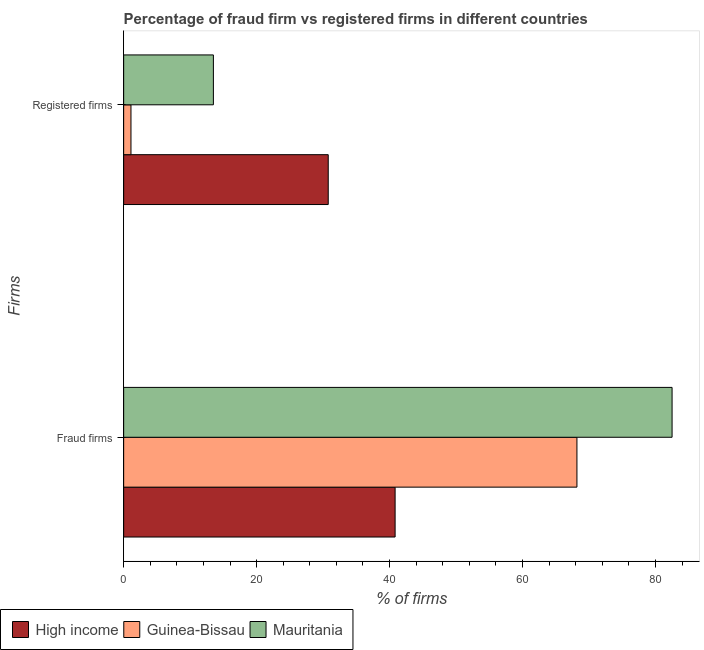Are the number of bars per tick equal to the number of legend labels?
Ensure brevity in your answer.  Yes. Are the number of bars on each tick of the Y-axis equal?
Offer a very short reply. Yes. How many bars are there on the 1st tick from the top?
Keep it short and to the point. 3. What is the label of the 2nd group of bars from the top?
Provide a succinct answer. Fraud firms. Across all countries, what is the maximum percentage of fraud firms?
Keep it short and to the point. 82.5. Across all countries, what is the minimum percentage of fraud firms?
Offer a very short reply. 40.84. In which country was the percentage of fraud firms maximum?
Provide a short and direct response. Mauritania. What is the total percentage of registered firms in the graph?
Ensure brevity in your answer.  45.38. What is the difference between the percentage of fraud firms in High income and that in Guinea-Bissau?
Your response must be concise. -27.35. What is the difference between the percentage of registered firms in Mauritania and the percentage of fraud firms in Guinea-Bissau?
Your answer should be very brief. -54.69. What is the average percentage of registered firms per country?
Provide a short and direct response. 15.12. What is the difference between the percentage of fraud firms and percentage of registered firms in High income?
Offer a terse response. 10.06. In how many countries, is the percentage of registered firms greater than 12 %?
Offer a terse response. 2. What is the ratio of the percentage of registered firms in Mauritania to that in Guinea-Bissau?
Your response must be concise. 12.27. Is the percentage of fraud firms in Mauritania less than that in High income?
Provide a succinct answer. No. In how many countries, is the percentage of fraud firms greater than the average percentage of fraud firms taken over all countries?
Keep it short and to the point. 2. How many bars are there?
Ensure brevity in your answer.  6. How many countries are there in the graph?
Keep it short and to the point. 3. What is the difference between two consecutive major ticks on the X-axis?
Offer a very short reply. 20. Does the graph contain any zero values?
Provide a succinct answer. No. Does the graph contain grids?
Your answer should be very brief. No. Where does the legend appear in the graph?
Provide a succinct answer. Bottom left. How many legend labels are there?
Provide a short and direct response. 3. What is the title of the graph?
Provide a short and direct response. Percentage of fraud firm vs registered firms in different countries. Does "Isle of Man" appear as one of the legend labels in the graph?
Ensure brevity in your answer.  No. What is the label or title of the X-axis?
Give a very brief answer. % of firms. What is the label or title of the Y-axis?
Provide a succinct answer. Firms. What is the % of firms in High income in Fraud firms?
Your answer should be very brief. 40.84. What is the % of firms in Guinea-Bissau in Fraud firms?
Provide a short and direct response. 68.19. What is the % of firms in Mauritania in Fraud firms?
Make the answer very short. 82.5. What is the % of firms of High income in Registered firms?
Your answer should be compact. 30.77. What is the % of firms in Guinea-Bissau in Registered firms?
Your answer should be very brief. 1.1. What is the % of firms of Mauritania in Registered firms?
Provide a short and direct response. 13.5. Across all Firms, what is the maximum % of firms in High income?
Provide a short and direct response. 40.84. Across all Firms, what is the maximum % of firms of Guinea-Bissau?
Your response must be concise. 68.19. Across all Firms, what is the maximum % of firms of Mauritania?
Keep it short and to the point. 82.5. Across all Firms, what is the minimum % of firms in High income?
Offer a very short reply. 30.77. What is the total % of firms in High income in the graph?
Ensure brevity in your answer.  71.61. What is the total % of firms of Guinea-Bissau in the graph?
Ensure brevity in your answer.  69.29. What is the total % of firms of Mauritania in the graph?
Your response must be concise. 96. What is the difference between the % of firms in High income in Fraud firms and that in Registered firms?
Provide a short and direct response. 10.06. What is the difference between the % of firms of Guinea-Bissau in Fraud firms and that in Registered firms?
Give a very brief answer. 67.09. What is the difference between the % of firms of Mauritania in Fraud firms and that in Registered firms?
Provide a succinct answer. 69. What is the difference between the % of firms in High income in Fraud firms and the % of firms in Guinea-Bissau in Registered firms?
Give a very brief answer. 39.74. What is the difference between the % of firms of High income in Fraud firms and the % of firms of Mauritania in Registered firms?
Your answer should be very brief. 27.34. What is the difference between the % of firms in Guinea-Bissau in Fraud firms and the % of firms in Mauritania in Registered firms?
Your answer should be compact. 54.69. What is the average % of firms in High income per Firms?
Keep it short and to the point. 35.81. What is the average % of firms of Guinea-Bissau per Firms?
Offer a terse response. 34.65. What is the difference between the % of firms of High income and % of firms of Guinea-Bissau in Fraud firms?
Make the answer very short. -27.35. What is the difference between the % of firms in High income and % of firms in Mauritania in Fraud firms?
Make the answer very short. -41.66. What is the difference between the % of firms in Guinea-Bissau and % of firms in Mauritania in Fraud firms?
Keep it short and to the point. -14.31. What is the difference between the % of firms of High income and % of firms of Guinea-Bissau in Registered firms?
Your answer should be compact. 29.68. What is the difference between the % of firms in High income and % of firms in Mauritania in Registered firms?
Give a very brief answer. 17.27. What is the difference between the % of firms in Guinea-Bissau and % of firms in Mauritania in Registered firms?
Your answer should be very brief. -12.4. What is the ratio of the % of firms in High income in Fraud firms to that in Registered firms?
Give a very brief answer. 1.33. What is the ratio of the % of firms in Guinea-Bissau in Fraud firms to that in Registered firms?
Your response must be concise. 61.99. What is the ratio of the % of firms of Mauritania in Fraud firms to that in Registered firms?
Offer a very short reply. 6.11. What is the difference between the highest and the second highest % of firms of High income?
Your answer should be compact. 10.06. What is the difference between the highest and the second highest % of firms of Guinea-Bissau?
Offer a very short reply. 67.09. What is the difference between the highest and the second highest % of firms in Mauritania?
Offer a terse response. 69. What is the difference between the highest and the lowest % of firms of High income?
Keep it short and to the point. 10.06. What is the difference between the highest and the lowest % of firms in Guinea-Bissau?
Keep it short and to the point. 67.09. What is the difference between the highest and the lowest % of firms in Mauritania?
Your answer should be compact. 69. 